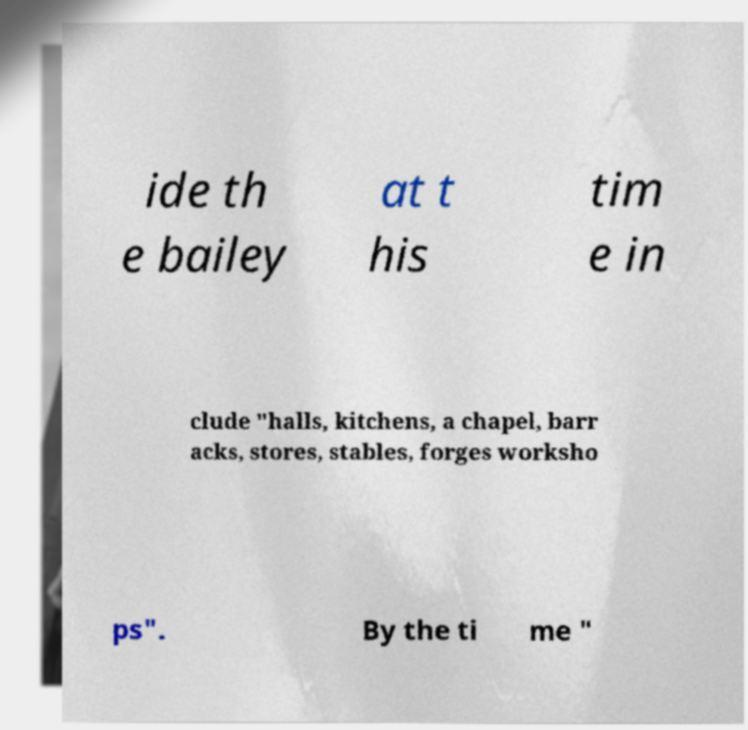Can you read and provide the text displayed in the image?This photo seems to have some interesting text. Can you extract and type it out for me? ide th e bailey at t his tim e in clude "halls, kitchens, a chapel, barr acks, stores, stables, forges worksho ps". By the ti me " 